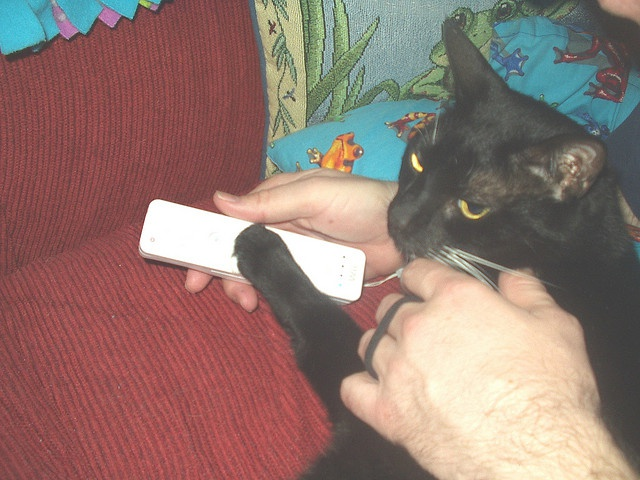Describe the objects in this image and their specific colors. I can see couch in lightblue, brown, teal, and darkgray tones, people in lightblue, beige, tan, and gray tones, cat in lightblue, gray, black, and darkgray tones, and remote in lightblue, white, darkgray, tan, and lightgray tones in this image. 